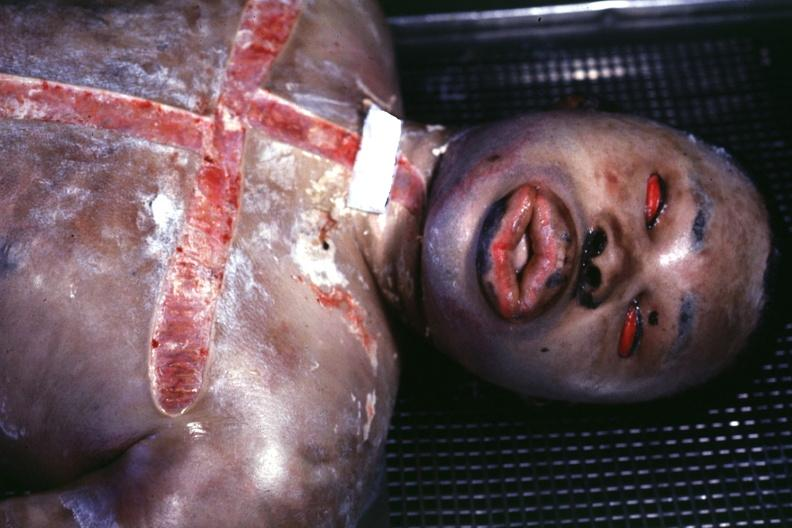s edema due to disseminated intravascular coagulation present?
Answer the question using a single word or phrase. Yes 